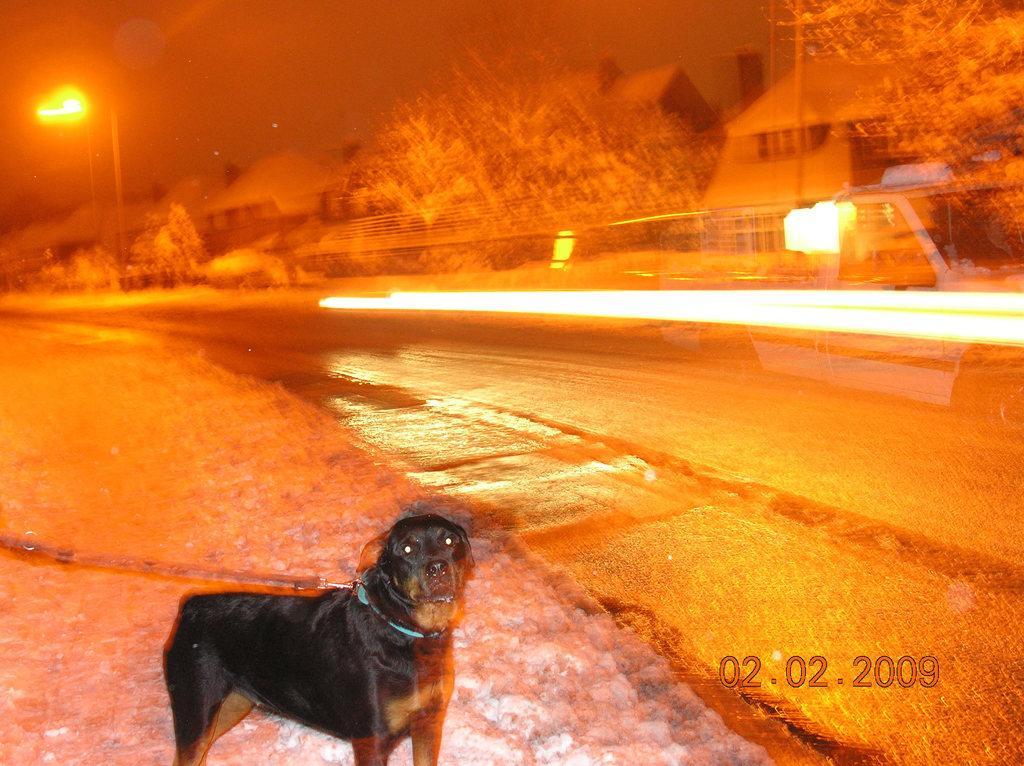Can you describe this image briefly? In this image I can see black color dog with the belt. To the right I can see the road. In the background I can see the trees, houses, poles and the sky. 